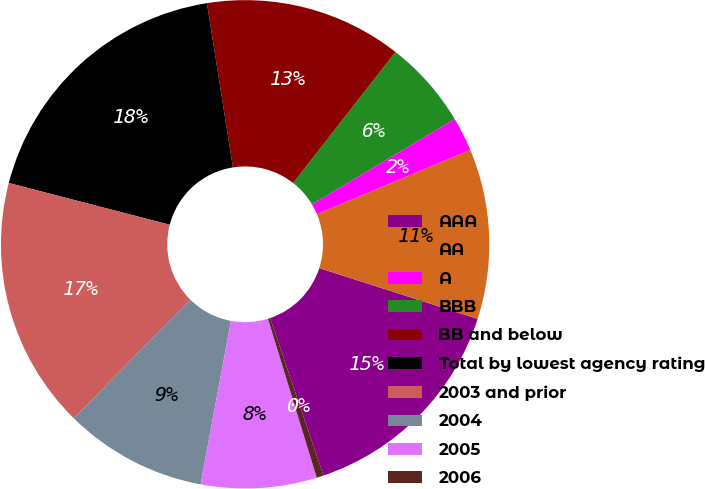<chart> <loc_0><loc_0><loc_500><loc_500><pie_chart><fcel>AAA<fcel>AA<fcel>A<fcel>BBB<fcel>BB and below<fcel>Total by lowest agency rating<fcel>2003 and prior<fcel>2004<fcel>2005<fcel>2006<nl><fcel>14.86%<fcel>11.26%<fcel>2.26%<fcel>5.86%<fcel>13.06%<fcel>18.46%<fcel>16.66%<fcel>9.46%<fcel>7.66%<fcel>0.46%<nl></chart> 